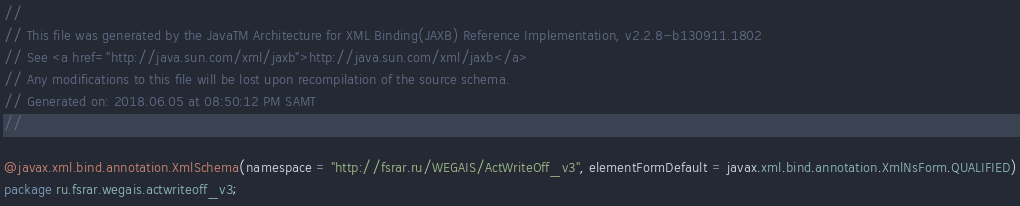Convert code to text. <code><loc_0><loc_0><loc_500><loc_500><_Java_>//
// This file was generated by the JavaTM Architecture for XML Binding(JAXB) Reference Implementation, v2.2.8-b130911.1802 
// See <a href="http://java.sun.com/xml/jaxb">http://java.sun.com/xml/jaxb</a> 
// Any modifications to this file will be lost upon recompilation of the source schema. 
// Generated on: 2018.06.05 at 08:50:12 PM SAMT 
//

@javax.xml.bind.annotation.XmlSchema(namespace = "http://fsrar.ru/WEGAIS/ActWriteOff_v3", elementFormDefault = javax.xml.bind.annotation.XmlNsForm.QUALIFIED)
package ru.fsrar.wegais.actwriteoff_v3;
</code> 